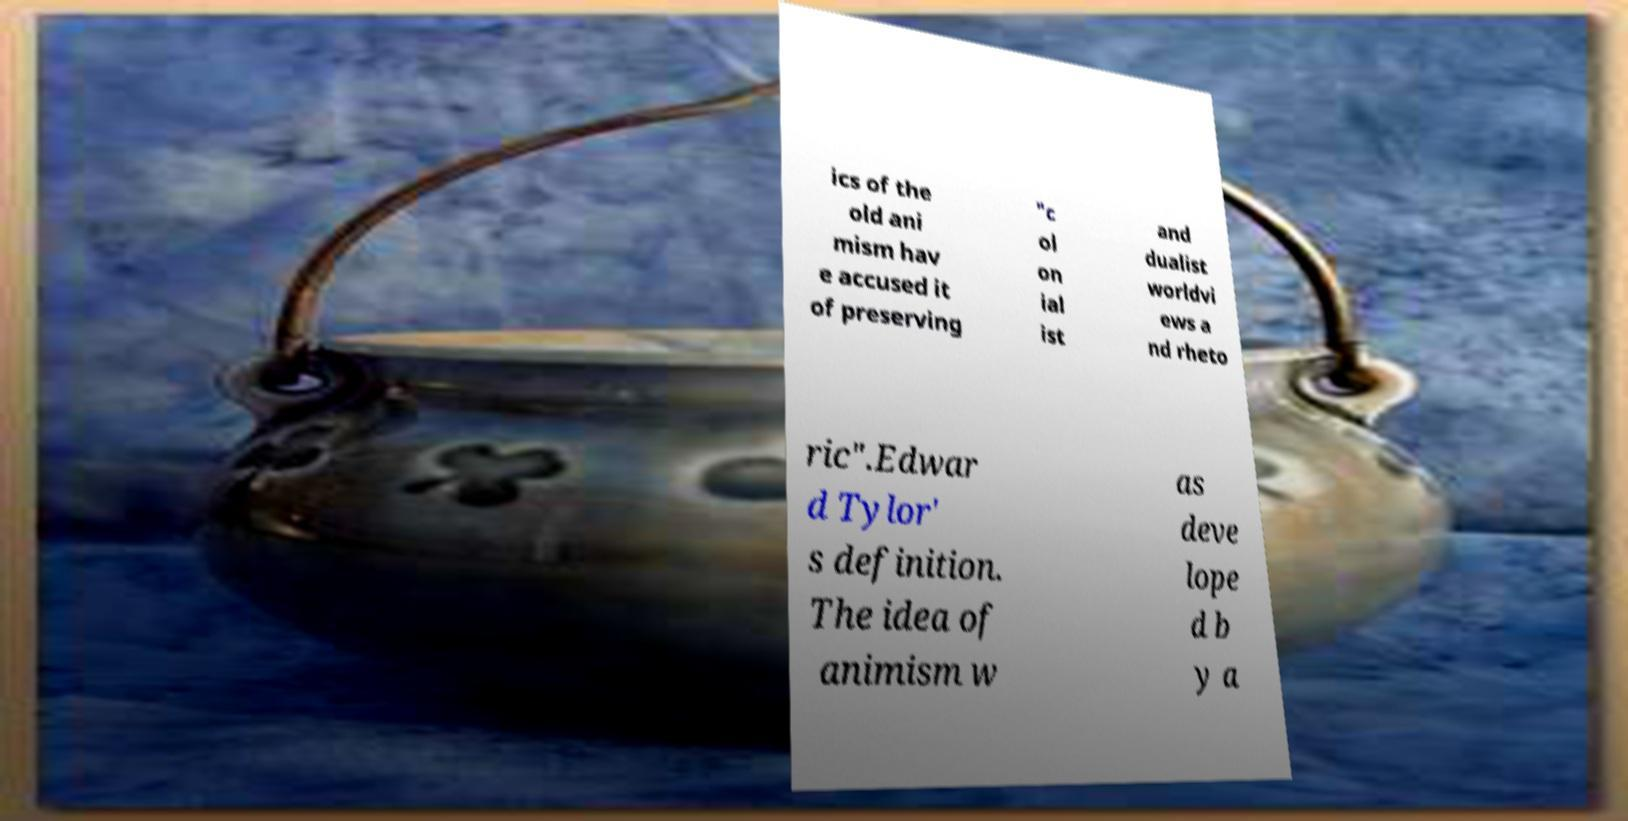Can you accurately transcribe the text from the provided image for me? ics of the old ani mism hav e accused it of preserving "c ol on ial ist and dualist worldvi ews a nd rheto ric".Edwar d Tylor' s definition. The idea of animism w as deve lope d b y a 